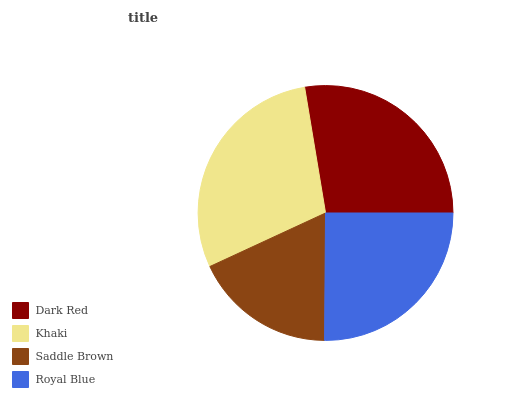Is Saddle Brown the minimum?
Answer yes or no. Yes. Is Khaki the maximum?
Answer yes or no. Yes. Is Khaki the minimum?
Answer yes or no. No. Is Saddle Brown the maximum?
Answer yes or no. No. Is Khaki greater than Saddle Brown?
Answer yes or no. Yes. Is Saddle Brown less than Khaki?
Answer yes or no. Yes. Is Saddle Brown greater than Khaki?
Answer yes or no. No. Is Khaki less than Saddle Brown?
Answer yes or no. No. Is Dark Red the high median?
Answer yes or no. Yes. Is Royal Blue the low median?
Answer yes or no. Yes. Is Royal Blue the high median?
Answer yes or no. No. Is Saddle Brown the low median?
Answer yes or no. No. 